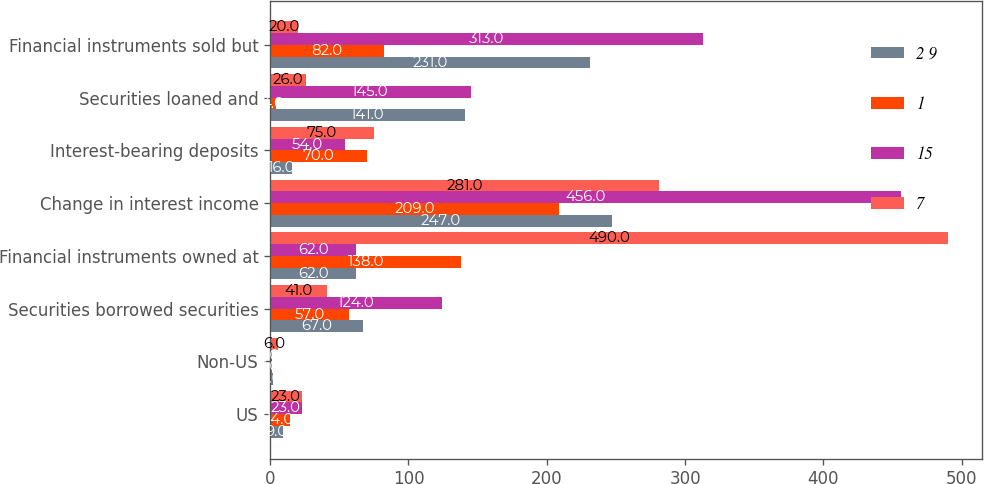<chart> <loc_0><loc_0><loc_500><loc_500><stacked_bar_chart><ecel><fcel>US<fcel>Non-US<fcel>Securities borrowed securities<fcel>Financial instruments owned at<fcel>Change in interest income<fcel>Interest-bearing deposits<fcel>Securities loaned and<fcel>Financial instruments sold but<nl><fcel>2 9<fcel>9<fcel>2<fcel>67<fcel>62<fcel>247<fcel>16<fcel>141<fcel>231<nl><fcel>1<fcel>14<fcel>1<fcel>57<fcel>138<fcel>209<fcel>70<fcel>4<fcel>82<nl><fcel>15<fcel>23<fcel>1<fcel>124<fcel>62<fcel>456<fcel>54<fcel>145<fcel>313<nl><fcel>7<fcel>23<fcel>6<fcel>41<fcel>490<fcel>281<fcel>75<fcel>26<fcel>20<nl></chart> 